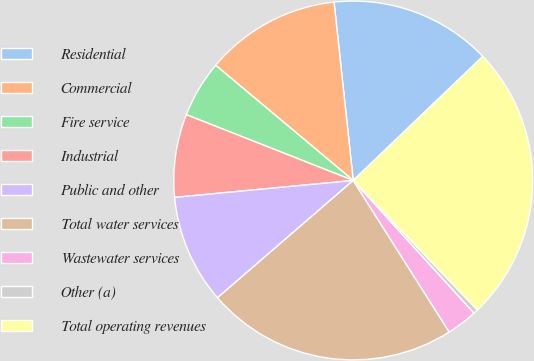<chart> <loc_0><loc_0><loc_500><loc_500><pie_chart><fcel>Residential<fcel>Commercial<fcel>Fire service<fcel>Industrial<fcel>Public and other<fcel>Total water services<fcel>Wastewater services<fcel>Other (a)<fcel>Total operating revenues<nl><fcel>14.55%<fcel>12.2%<fcel>5.12%<fcel>7.48%<fcel>9.84%<fcel>22.64%<fcel>2.77%<fcel>0.41%<fcel>24.99%<nl></chart> 